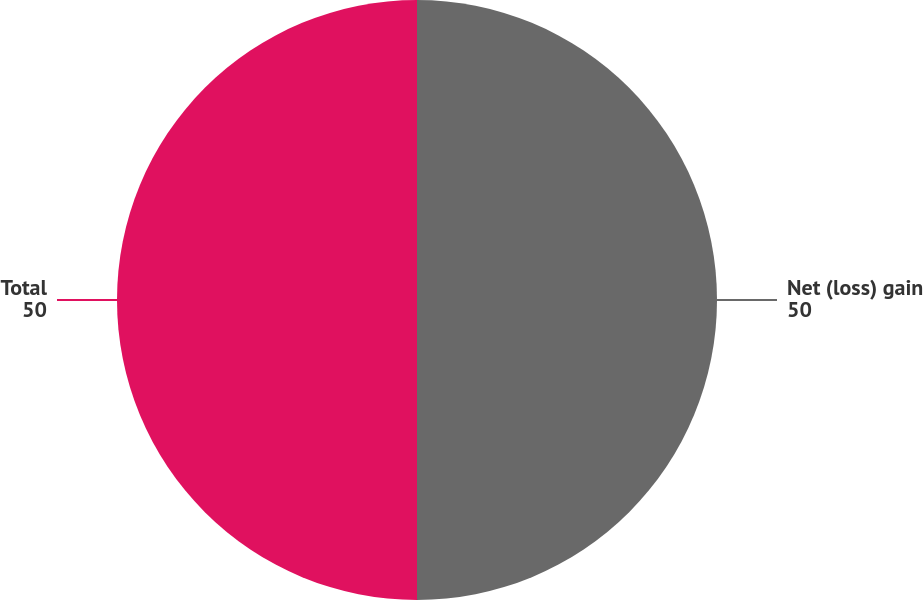Convert chart. <chart><loc_0><loc_0><loc_500><loc_500><pie_chart><fcel>Net (loss) gain<fcel>Total<nl><fcel>50.0%<fcel>50.0%<nl></chart> 